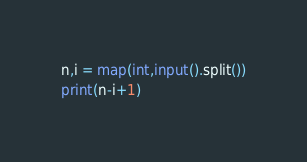Convert code to text. <code><loc_0><loc_0><loc_500><loc_500><_Python_>n,i = map(int,input().split())
print(n-i+1)</code> 